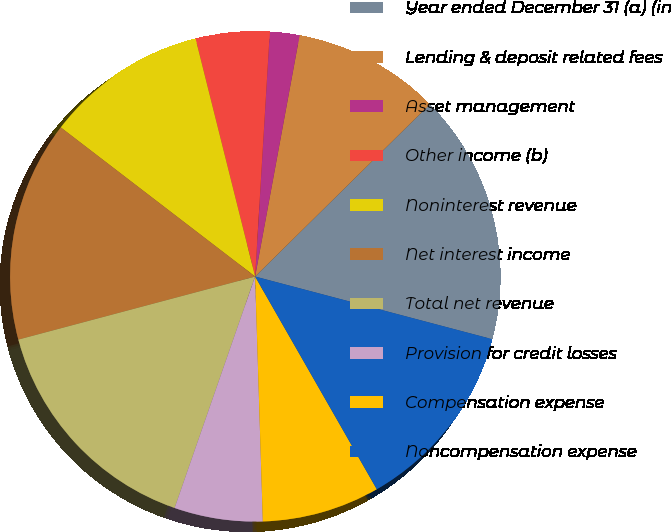Convert chart to OTSL. <chart><loc_0><loc_0><loc_500><loc_500><pie_chart><fcel>Year ended December 31 (a) (in<fcel>Lending & deposit related fees<fcel>Asset management<fcel>Other income (b)<fcel>Noninterest revenue<fcel>Net interest income<fcel>Total net revenue<fcel>Provision for credit losses<fcel>Compensation expense<fcel>Noncompensation expense<nl><fcel>16.5%<fcel>9.71%<fcel>1.95%<fcel>4.86%<fcel>10.68%<fcel>14.56%<fcel>15.53%<fcel>5.83%<fcel>7.77%<fcel>12.62%<nl></chart> 